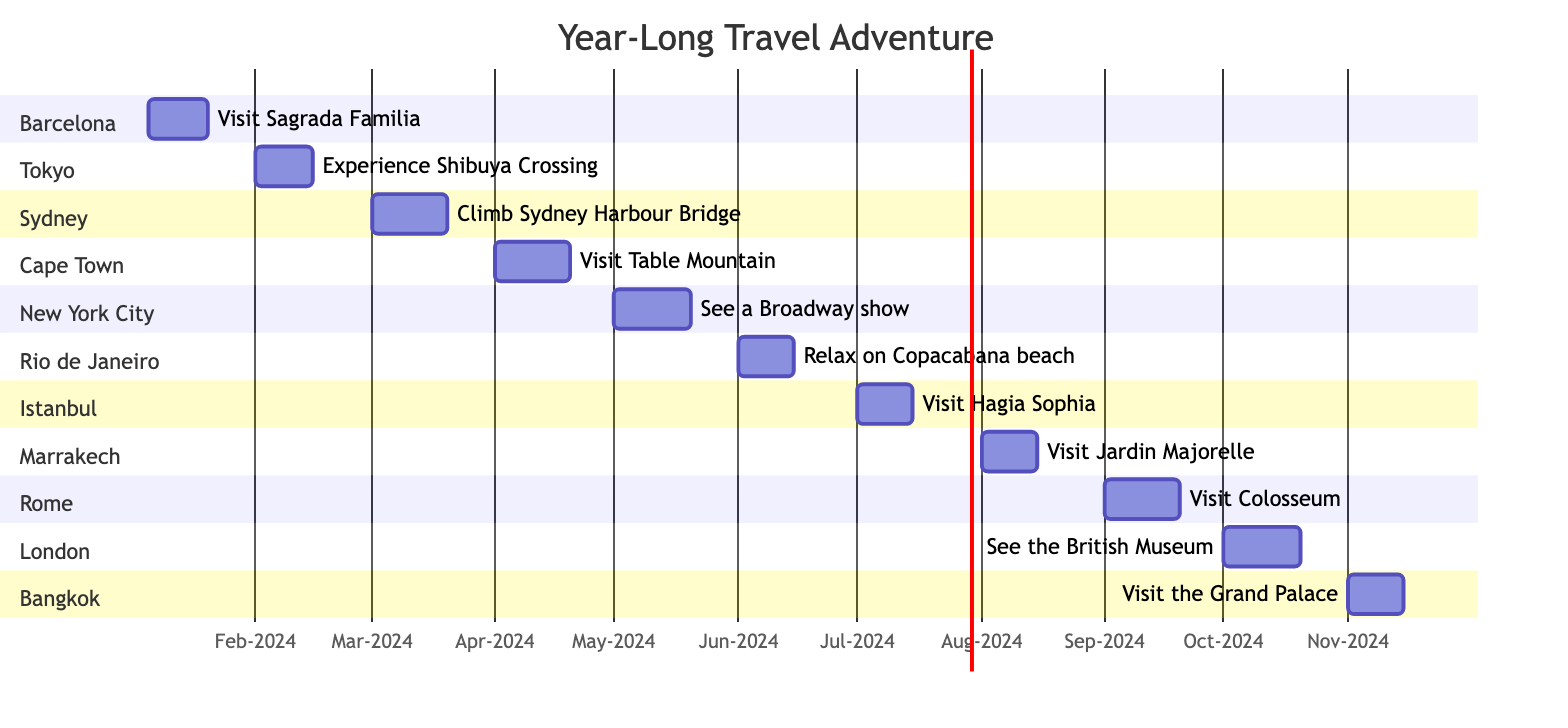What is the total budget allocated for the trip to Sydney? The budget for each destination is listed, and for Sydney, it explicitly states a budget of 1800.
Answer: 1800 Which destination starts on March 1st, 2024? By examining the timeline of the Gantt Chart, Sydney is the destination that starts on March 1st, 2024.
Answer: Sydney How many activities are planned for the trip to Barcelona? The destination of Barcelona lists three activities: Visit Sagrada Familia, Explore Park Güell, and Enjoy tapas at La Boqueria.
Answer: 3 Which destination has the lowest budget? Comparing all the budgets given for each destination, Marrakech, Morocco has the lowest budget of 1200.
Answer: 1200 What is the duration of the trip to Cape Town? The start date is April 1st, 2024, and the end date is April 20th, 2024. This duration is 20 days.
Answer: 20 days Which two destinations are planned back-to-back within two consecutive months? The destinations of Rio de Janeiro and Istanbul are back-to-back as Rio is scheduled for June and Istanbul starts in July.
Answer: Rio de Janeiro and Istanbul In which month does the travel to New York City begin? The schedule indicates that the trip to New York City starts on May 1st, 2024, which falls in May.
Answer: May How many days are allocated for the visit to Bangkok? The trip to Bangkok is set to begin on November 1st and end on November 15th, giving a duration of 14 days.
Answer: 14 days Which destination is scheduled to occur last in the timeline? According to the timeline, the last destination is Bangkok, which is scheduled for November 2024.
Answer: Bangkok 